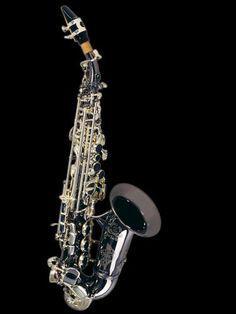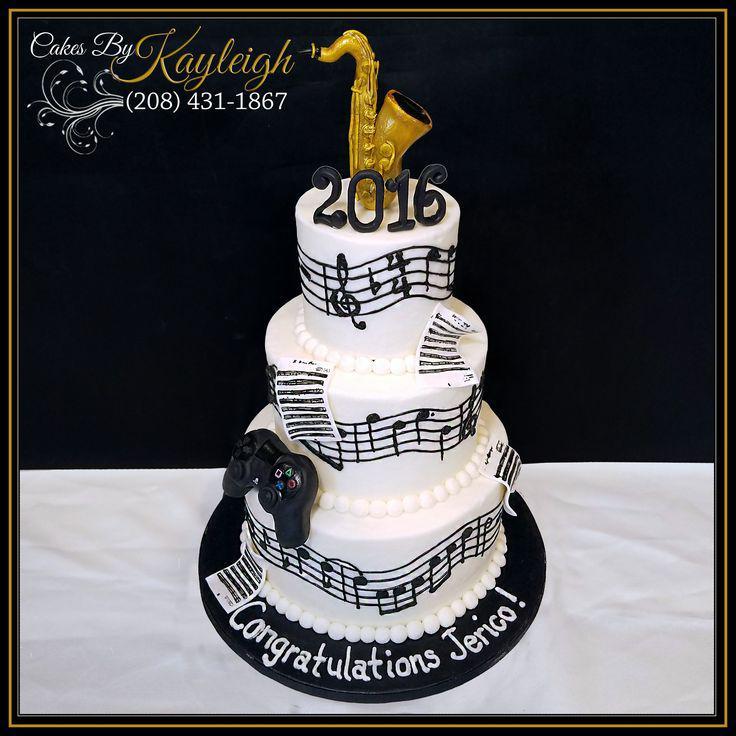The first image is the image on the left, the second image is the image on the right. Evaluate the accuracy of this statement regarding the images: "A total of at least three mouthpieces are shown separate from a saxophone.". Is it true? Answer yes or no. No. The first image is the image on the left, the second image is the image on the right. Examine the images to the left and right. Is the description "There are less than five musical instruments." accurate? Answer yes or no. Yes. 